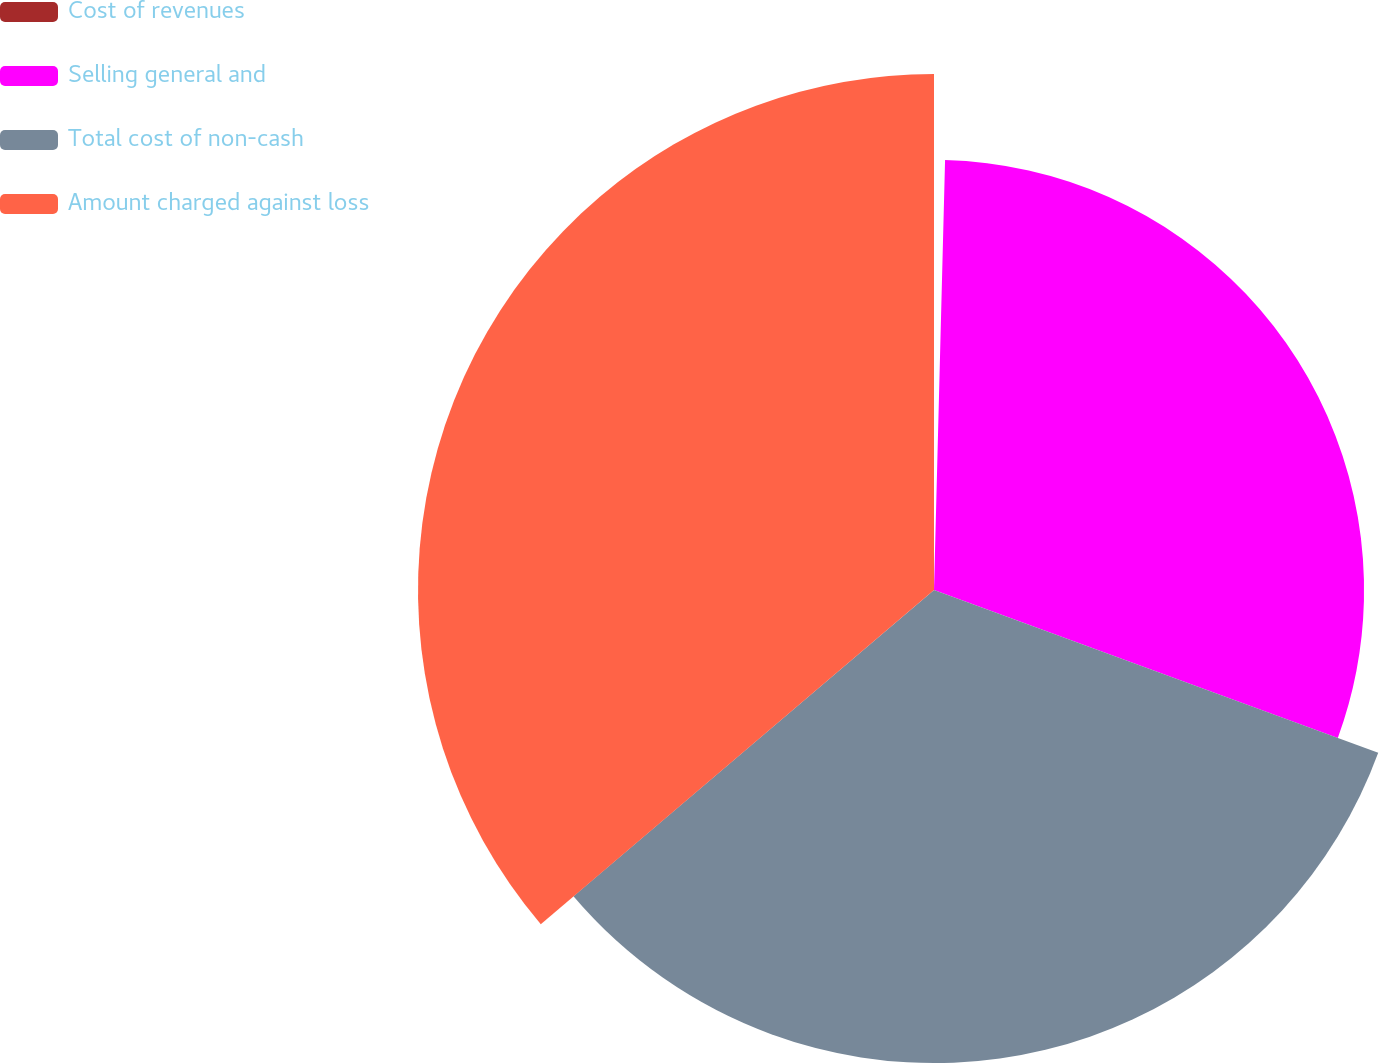Convert chart. <chart><loc_0><loc_0><loc_500><loc_500><pie_chart><fcel>Cost of revenues<fcel>Selling general and<fcel>Total cost of non-cash<fcel>Amount charged against loss<nl><fcel>0.41%<fcel>30.18%<fcel>33.2%<fcel>36.21%<nl></chart> 